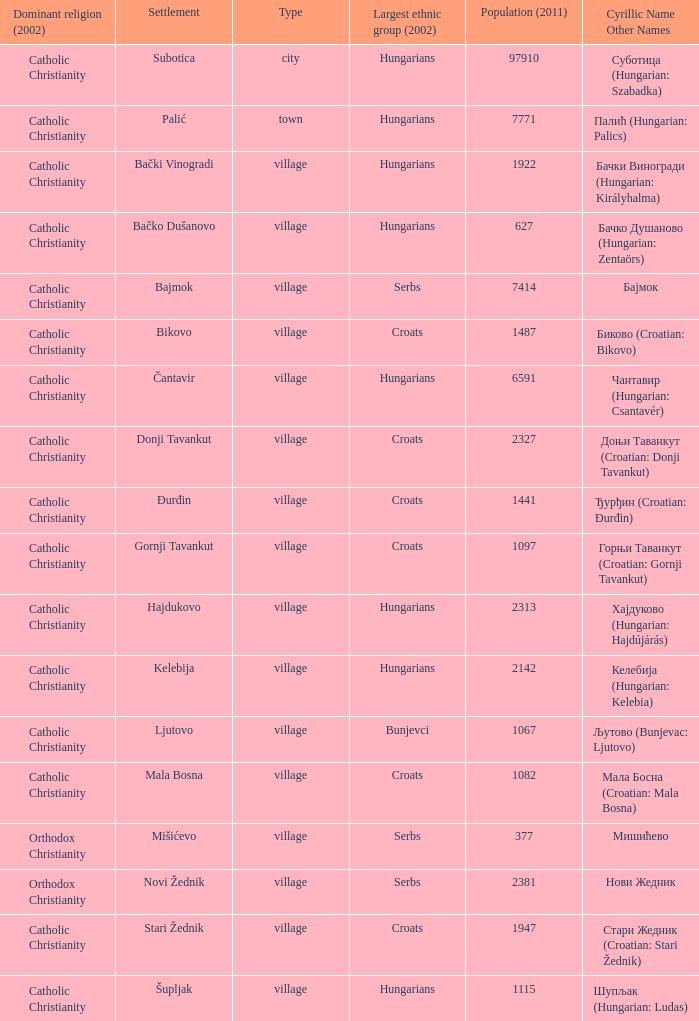What type of settlement has a population of 1441? Village. 